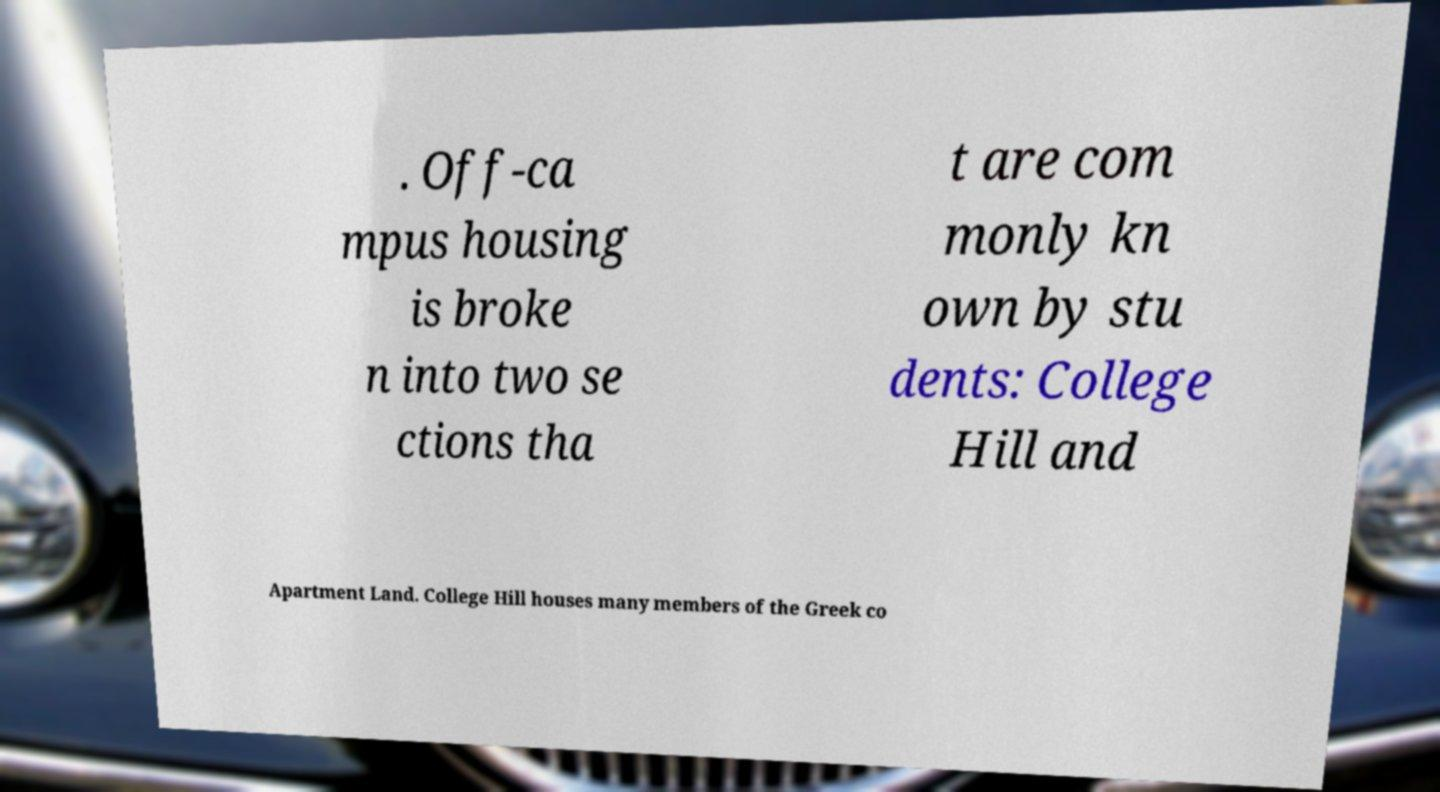Please read and relay the text visible in this image. What does it say? . Off-ca mpus housing is broke n into two se ctions tha t are com monly kn own by stu dents: College Hill and Apartment Land. College Hill houses many members of the Greek co 